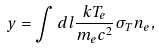Convert formula to latex. <formula><loc_0><loc_0><loc_500><loc_500>y = \int d l \frac { k T _ { e } } { m _ { e } c ^ { 2 } } \sigma _ { T } n _ { e } ,</formula> 